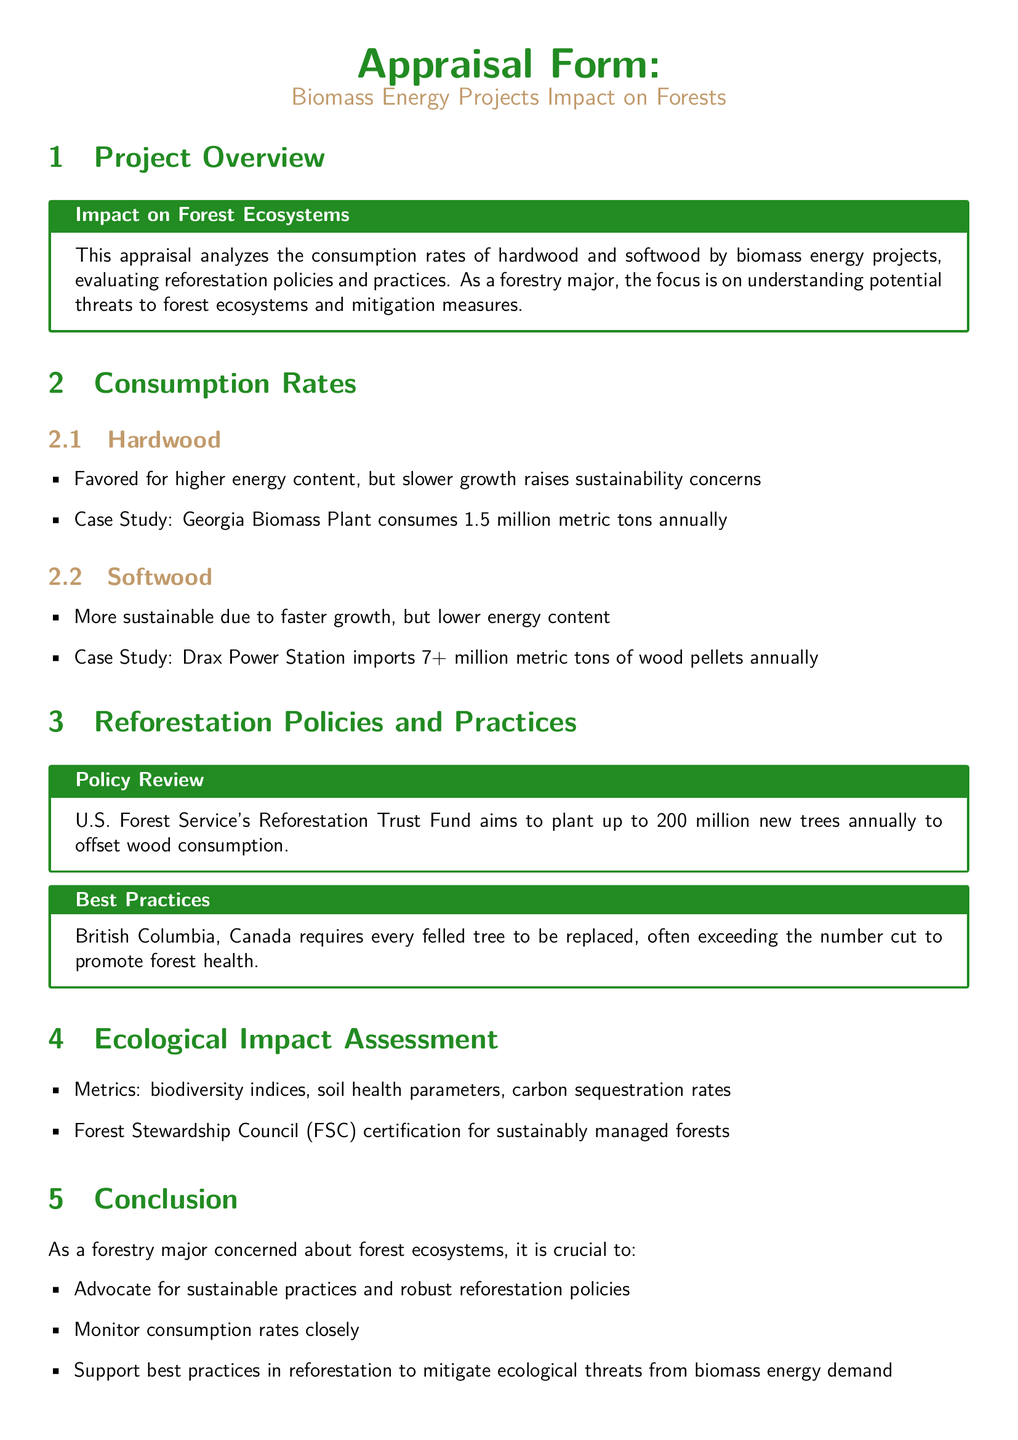What is the consumption rate of hardwood at Georgia Biomass Plant? The document states that Georgia Biomass Plant consumes 1.5 million metric tons annually for hardwood.
Answer: 1.5 million metric tons How many trees does the U.S. Forest Service aim to plant annually? According to the policy review, the U.S. Forest Service aims to plant up to 200 million new trees annually.
Answer: 200 million What is the focus of this appraisal form? This document focuses on analyzing the consumption rates of hardwood and softwood by biomass energy projects and evaluating reforestation policies and practices.
Answer: Biomass energy projects and reforestation Which certification is mentioned for sustainably managed forests? The document mentions the Forest Stewardship Council certification as a standard for sustainably managed forests.
Answer: Forest Stewardship Council What is a key concern about hardwood consumption? The appraisal highlights that hardwood is favored for its higher energy content but raises sustainability concerns due to its slower growth.
Answer: Sustainability concerns What is one best practice for reforestation mentioned? The document states that British Columbia, Canada requires every felled tree to be replaced, often exceeding the number cut.
Answer: Every felled tree must be replaced How does the document suggest mitigating ecological threats from biomass energy demand? The conclusion emphasizes advocating for sustainable practices, monitoring consumption rates, and supporting best reforestation practices as mitigation measures.
Answer: Advocate for sustainable practices What type of assessments are included in the ecological impact assessment? The document lists metrics such as biodiversity indices, soil health parameters, and carbon sequestration rates as part of the ecological impact assessment.
Answer: Biodiversity indices, soil health parameters, carbon sequestration rates How much wood does Drax Power Station import annually? The document mentions that Drax Power Station imports over 7 million metric tons of wood pellets annually.
Answer: 7+ million metric tons 